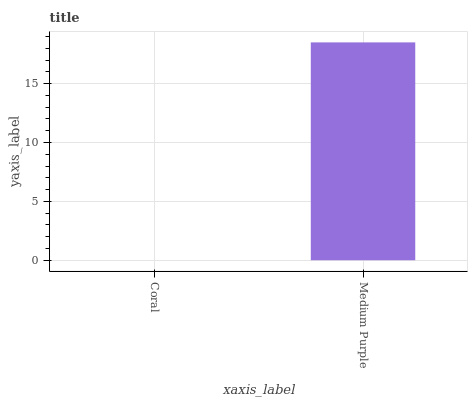Is Coral the minimum?
Answer yes or no. Yes. Is Medium Purple the maximum?
Answer yes or no. Yes. Is Medium Purple the minimum?
Answer yes or no. No. Is Medium Purple greater than Coral?
Answer yes or no. Yes. Is Coral less than Medium Purple?
Answer yes or no. Yes. Is Coral greater than Medium Purple?
Answer yes or no. No. Is Medium Purple less than Coral?
Answer yes or no. No. Is Medium Purple the high median?
Answer yes or no. Yes. Is Coral the low median?
Answer yes or no. Yes. Is Coral the high median?
Answer yes or no. No. Is Medium Purple the low median?
Answer yes or no. No. 